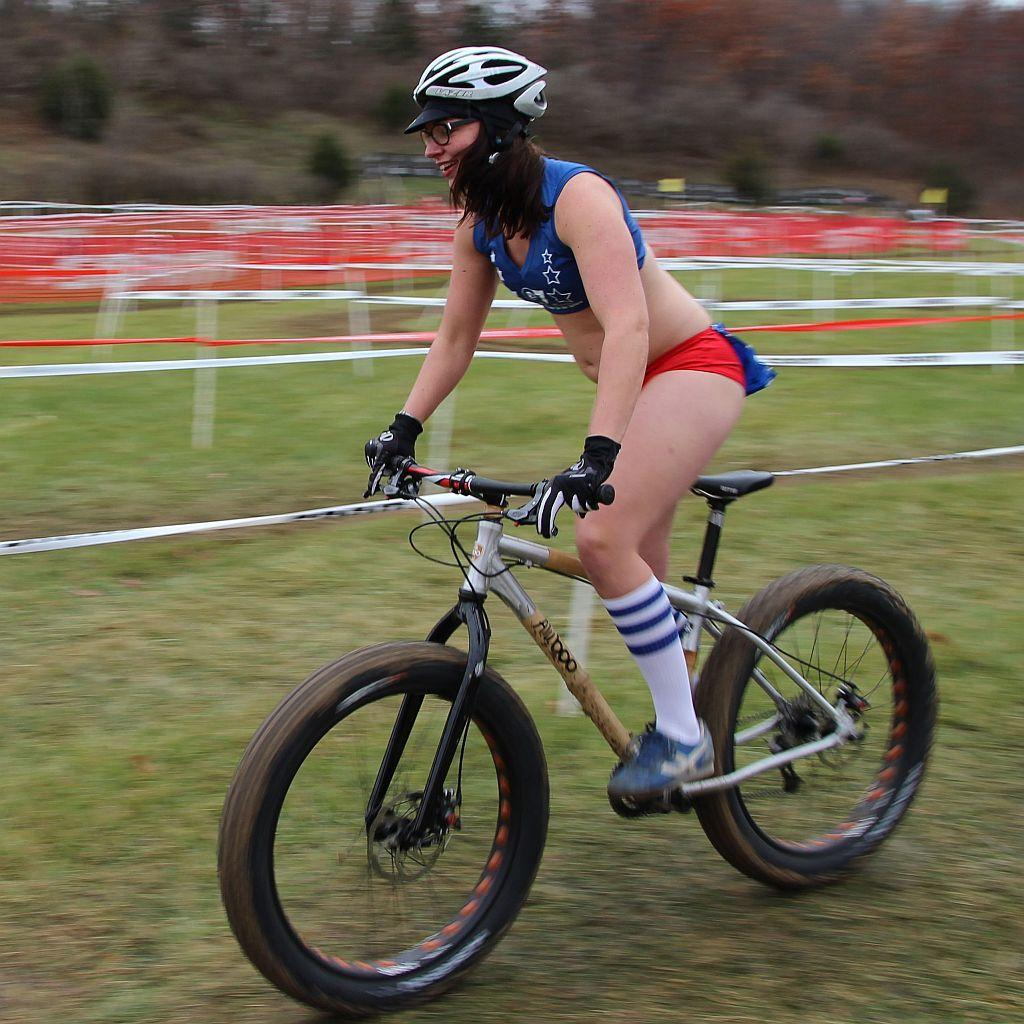What type of vegetation can be seen in the image? There are trees in the image. What activity is the woman in the image engaged in? The woman is riding a bicycle in the image. What type of print is visible on the woman's shirt as she rides the bicycle in the image? There is no information about the woman's shirt or any print on it in the provided facts. --- 